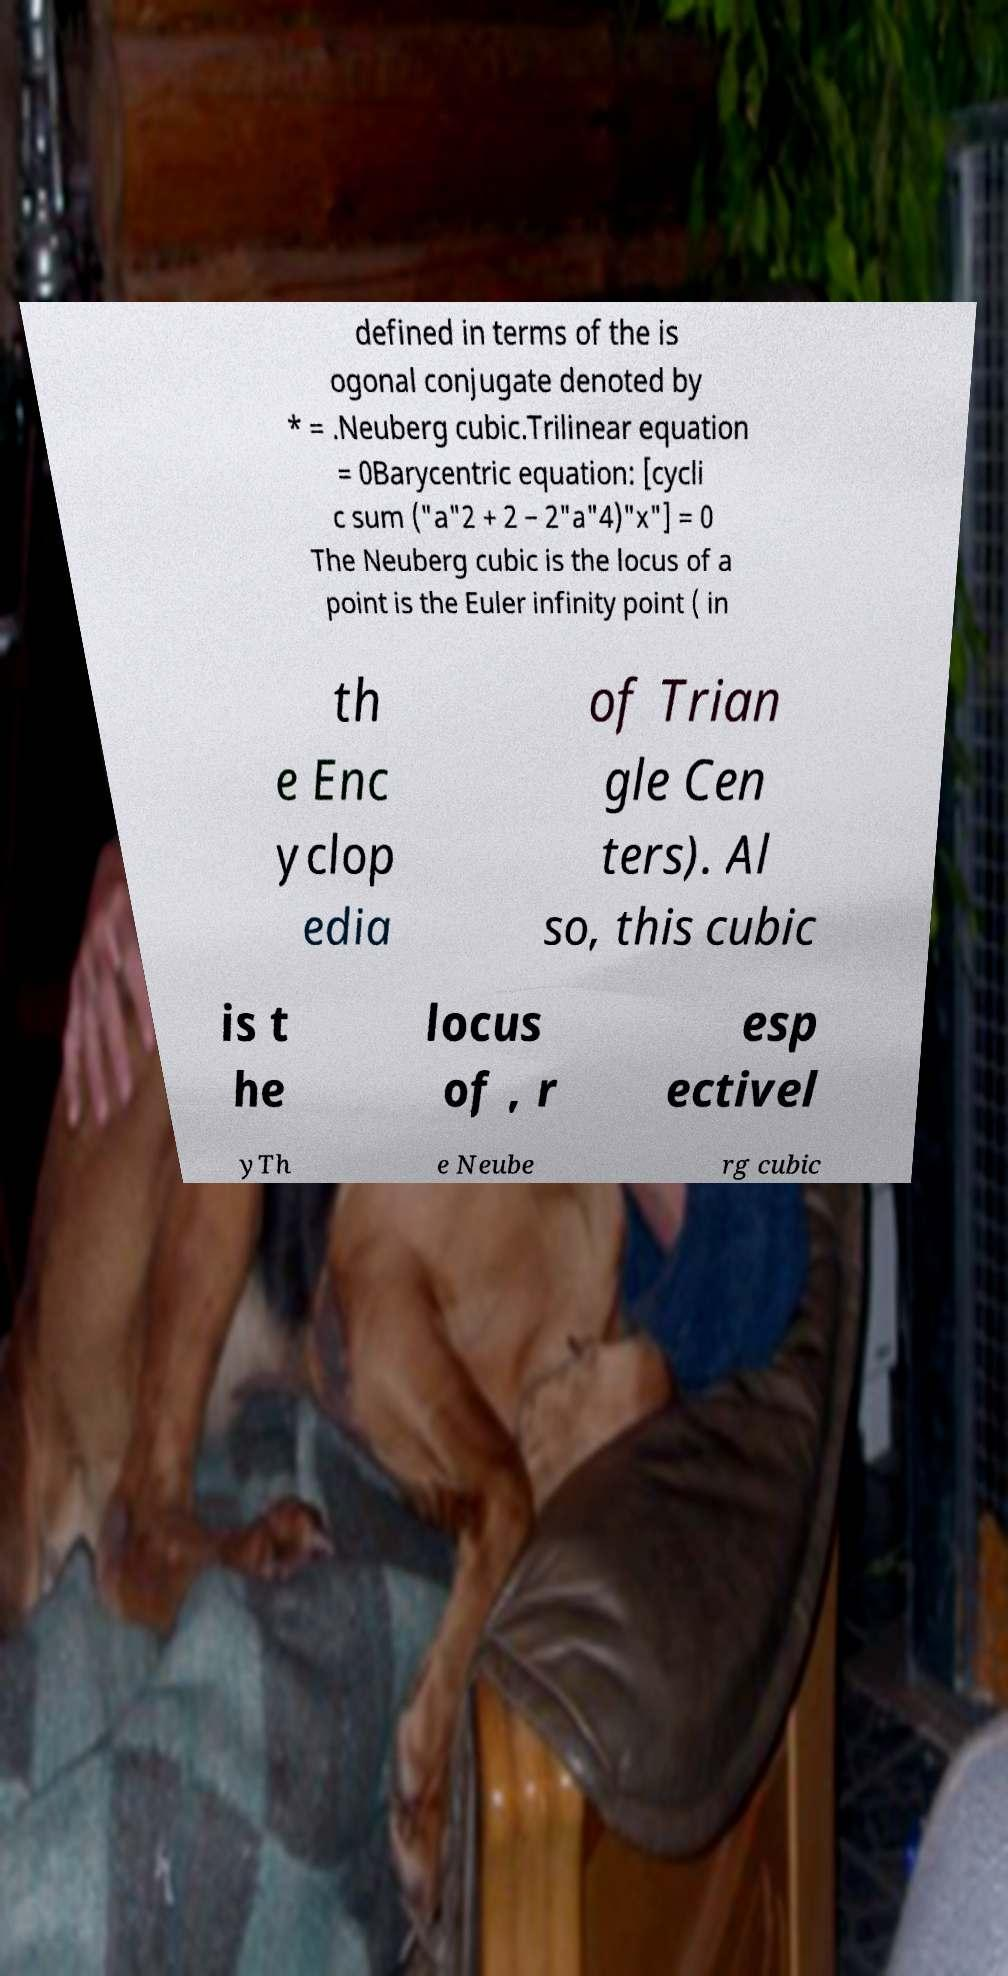Can you accurately transcribe the text from the provided image for me? defined in terms of the is ogonal conjugate denoted by * = .Neuberg cubic.Trilinear equation = 0Barycentric equation: [cycli c sum ("a"2 + 2 − 2"a"4)"x"] = 0 The Neuberg cubic is the locus of a point is the Euler infinity point ( in th e Enc yclop edia of Trian gle Cen ters). Al so, this cubic is t he locus of , r esp ectivel yTh e Neube rg cubic 